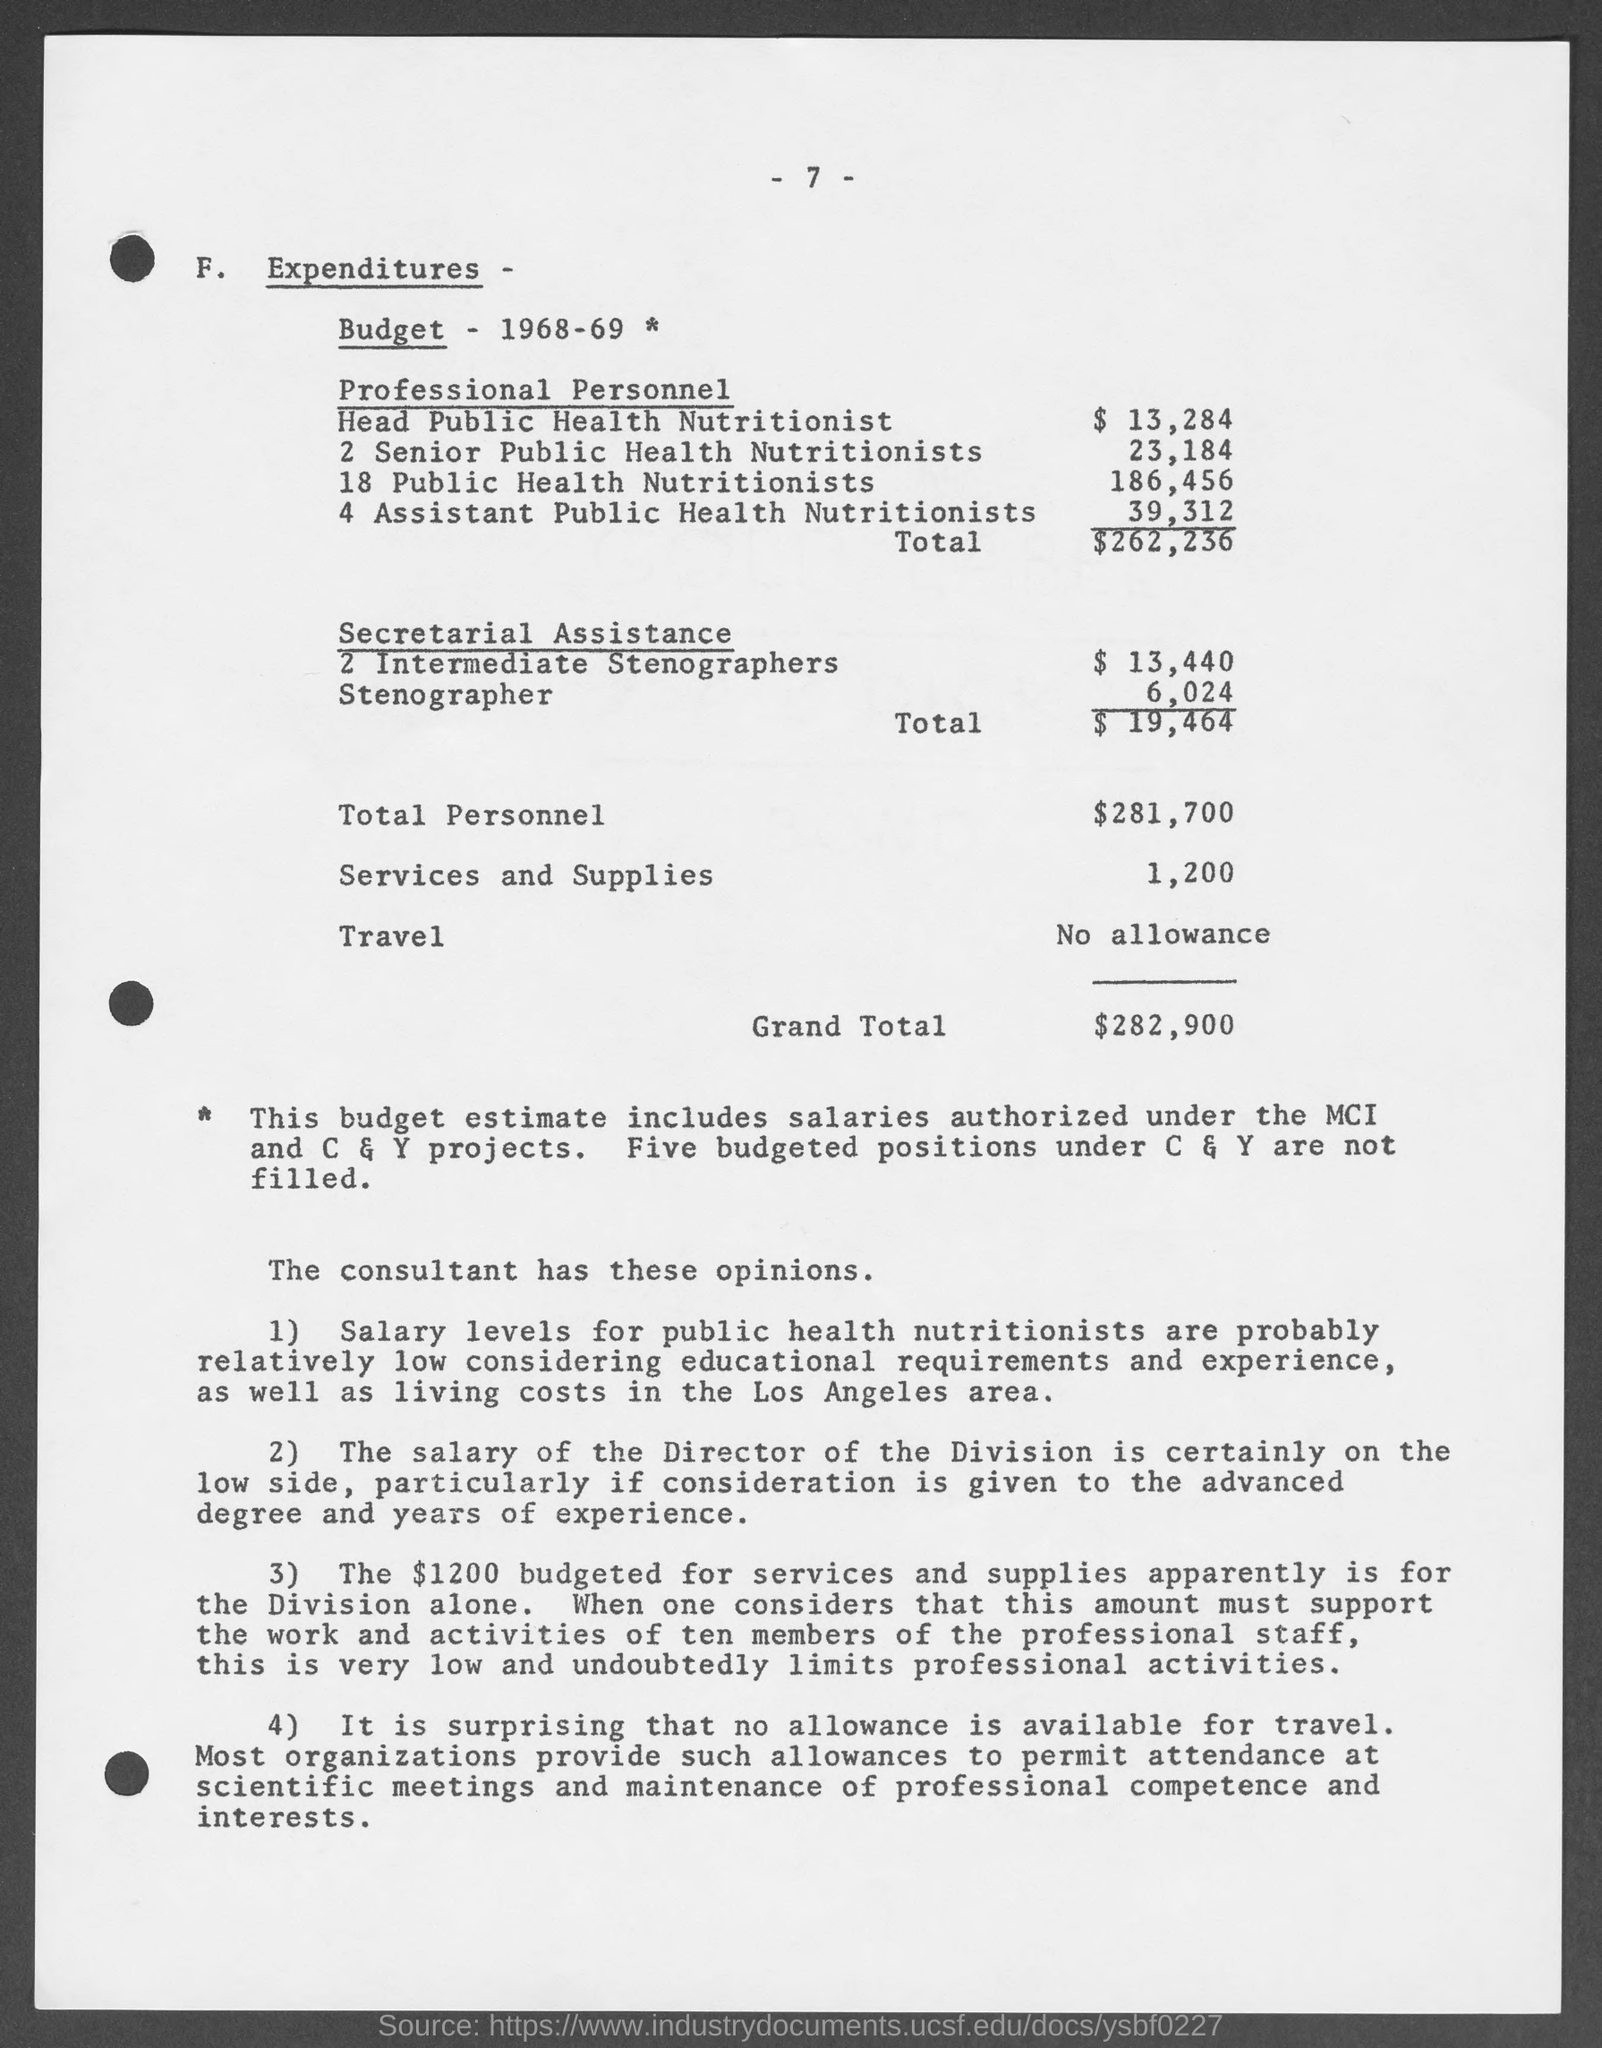What is the budget estimate for Head Public Health Nutritionist in the year 1968-69?
Your answer should be very brief. 13,284. What is the budget estimate for 18 Public Health Nutritionist in the year 1968-69?
Your answer should be very brief. 186,456. What is the total budget estimate for professional personnel in the year 1968-69?
Offer a terse response. 262,236. What is the Budget Estimate for Stenographer in the year 1968-69?
Make the answer very short. 6,024. What is the total budget estimate for Secretarial Assistance in the year 1968-69?
Offer a terse response. 19,464. What is the total personnel budget for the year 1968-69?
Your answer should be compact. 281,700. What is the budget estimate for services and supplies in the year 1968-69?
Offer a terse response. 1,200. 